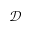Convert formula to latex. <formula><loc_0><loc_0><loc_500><loc_500>\mathcal { D }</formula> 